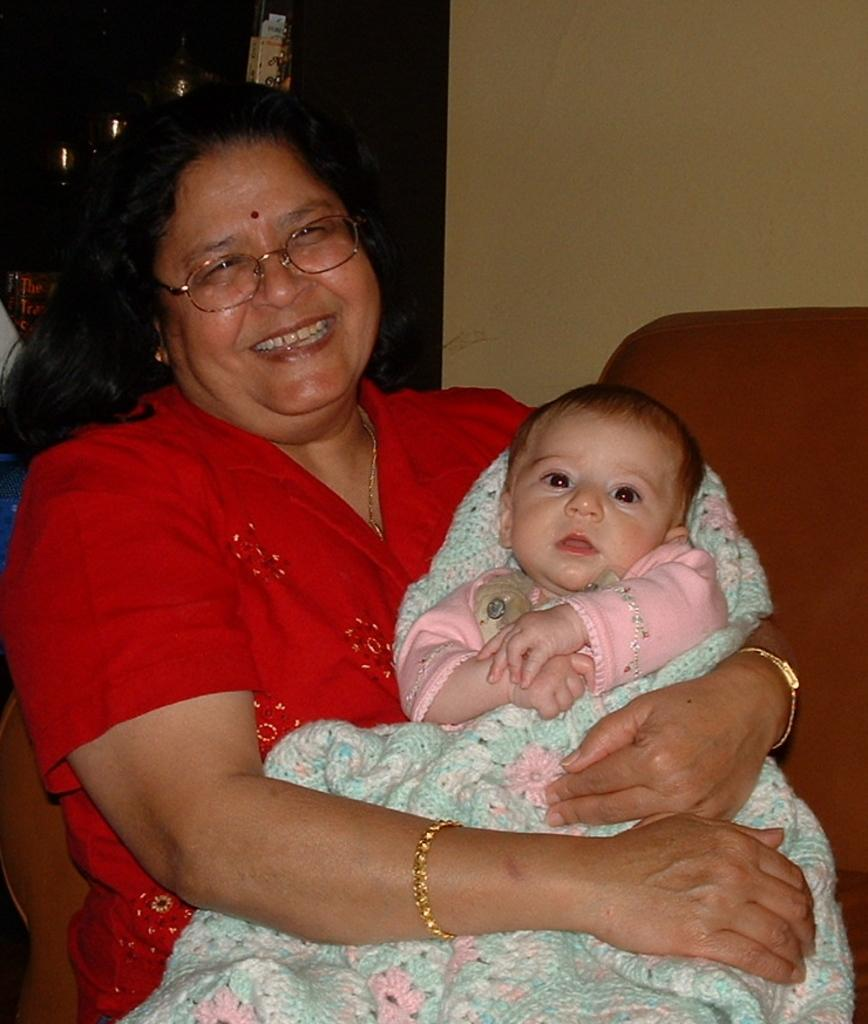Who or what can be seen in the image? There are people in the image. What is the primary architectural feature in the image? There is a wall in the image. What type of furniture is present in the image? There is a chair in the image. Can you describe the background of the image? There are objects visible in the background of the image. What type of prison system is depicted in the image? There is no prison or prison system present in the image. How does the rubbing of the objects in the image affect the system? There is no rubbing or system mentioned in the image; it only features people, a wall, a chair, and objects in the background. 